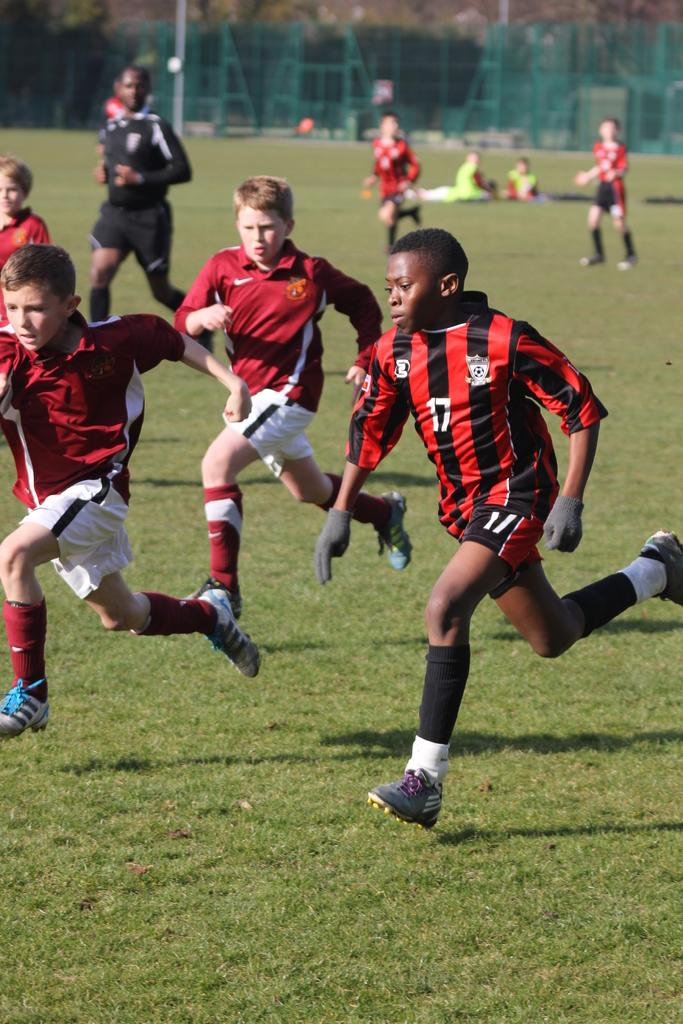<image>
Summarize the visual content of the image. a boy that has the number 17 on their jersey 